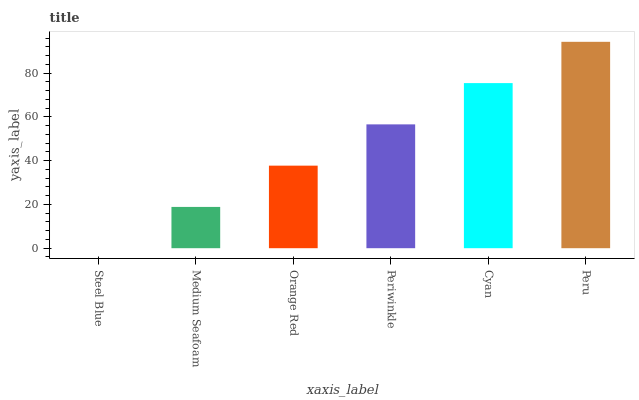Is Steel Blue the minimum?
Answer yes or no. Yes. Is Peru the maximum?
Answer yes or no. Yes. Is Medium Seafoam the minimum?
Answer yes or no. No. Is Medium Seafoam the maximum?
Answer yes or no. No. Is Medium Seafoam greater than Steel Blue?
Answer yes or no. Yes. Is Steel Blue less than Medium Seafoam?
Answer yes or no. Yes. Is Steel Blue greater than Medium Seafoam?
Answer yes or no. No. Is Medium Seafoam less than Steel Blue?
Answer yes or no. No. Is Periwinkle the high median?
Answer yes or no. Yes. Is Orange Red the low median?
Answer yes or no. Yes. Is Steel Blue the high median?
Answer yes or no. No. Is Peru the low median?
Answer yes or no. No. 